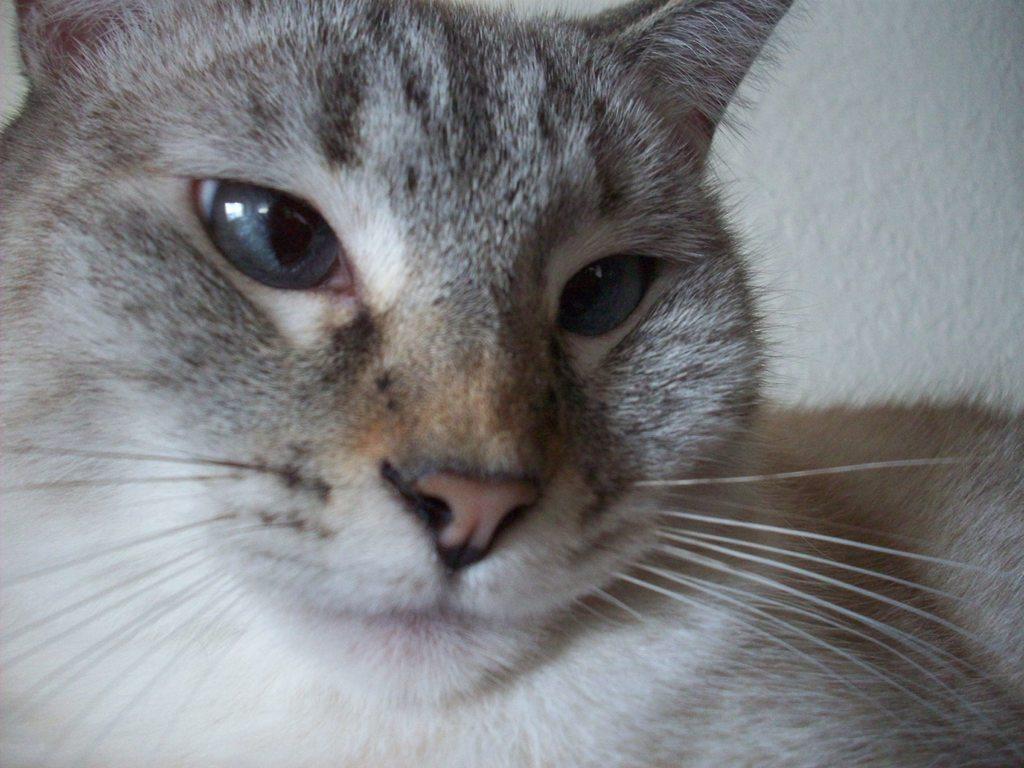Please provide a concise description of this image. This is the zoomed image of a cat and this cat is looking at the camera. In the background, it is white in color. 